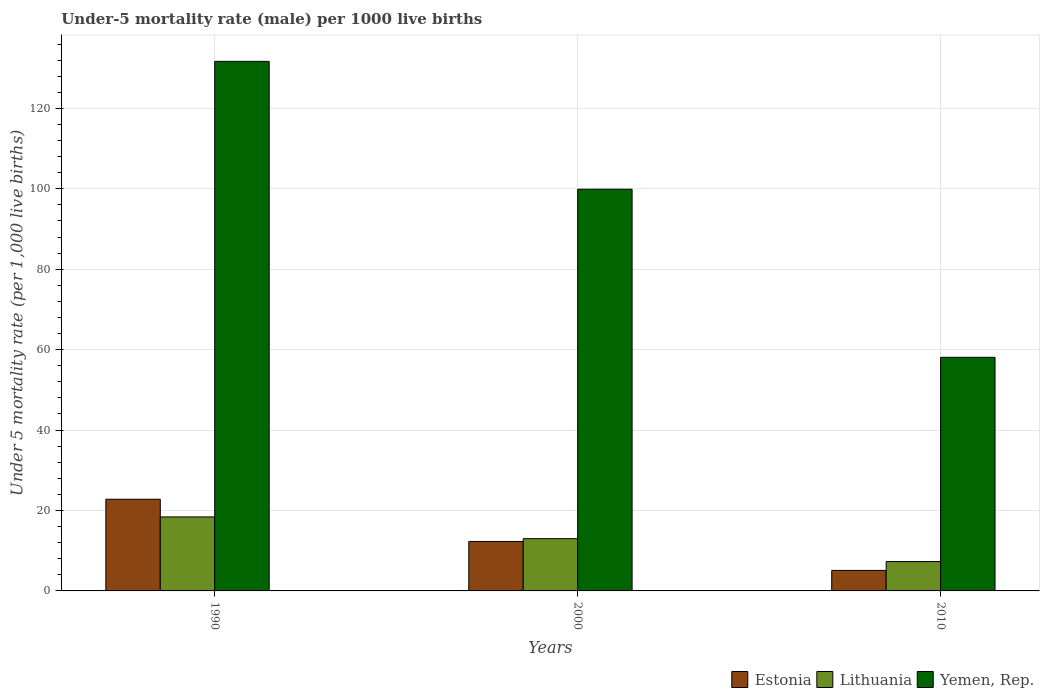How many groups of bars are there?
Give a very brief answer. 3. Are the number of bars per tick equal to the number of legend labels?
Offer a very short reply. Yes. How many bars are there on the 1st tick from the left?
Offer a terse response. 3. What is the label of the 3rd group of bars from the left?
Give a very brief answer. 2010. Across all years, what is the minimum under-five mortality rate in Lithuania?
Keep it short and to the point. 7.3. In which year was the under-five mortality rate in Lithuania maximum?
Offer a terse response. 1990. What is the total under-five mortality rate in Lithuania in the graph?
Make the answer very short. 38.7. What is the difference between the under-five mortality rate in Estonia in 2000 and that in 2010?
Ensure brevity in your answer.  7.2. What is the difference between the under-five mortality rate in Lithuania in 2000 and the under-five mortality rate in Estonia in 1990?
Make the answer very short. -9.8. What is the average under-five mortality rate in Lithuania per year?
Your answer should be very brief. 12.9. In the year 2000, what is the difference between the under-five mortality rate in Yemen, Rep. and under-five mortality rate in Estonia?
Keep it short and to the point. 87.6. What is the ratio of the under-five mortality rate in Lithuania in 1990 to that in 2000?
Your answer should be very brief. 1.42. Is the difference between the under-five mortality rate in Yemen, Rep. in 1990 and 2010 greater than the difference between the under-five mortality rate in Estonia in 1990 and 2010?
Your response must be concise. Yes. What is the difference between the highest and the second highest under-five mortality rate in Lithuania?
Ensure brevity in your answer.  5.4. What is the difference between the highest and the lowest under-five mortality rate in Estonia?
Your response must be concise. 17.7. What does the 3rd bar from the left in 2000 represents?
Provide a short and direct response. Yemen, Rep. What does the 2nd bar from the right in 2000 represents?
Make the answer very short. Lithuania. How many bars are there?
Offer a terse response. 9. Are all the bars in the graph horizontal?
Your response must be concise. No. How many years are there in the graph?
Ensure brevity in your answer.  3. Does the graph contain grids?
Keep it short and to the point. Yes. How are the legend labels stacked?
Provide a succinct answer. Horizontal. What is the title of the graph?
Give a very brief answer. Under-5 mortality rate (male) per 1000 live births. Does "Zimbabwe" appear as one of the legend labels in the graph?
Provide a short and direct response. No. What is the label or title of the Y-axis?
Provide a succinct answer. Under 5 mortality rate (per 1,0 live births). What is the Under 5 mortality rate (per 1,000 live births) in Estonia in 1990?
Offer a terse response. 22.8. What is the Under 5 mortality rate (per 1,000 live births) in Yemen, Rep. in 1990?
Ensure brevity in your answer.  131.7. What is the Under 5 mortality rate (per 1,000 live births) in Estonia in 2000?
Make the answer very short. 12.3. What is the Under 5 mortality rate (per 1,000 live births) of Lithuania in 2000?
Provide a short and direct response. 13. What is the Under 5 mortality rate (per 1,000 live births) of Yemen, Rep. in 2000?
Ensure brevity in your answer.  99.9. What is the Under 5 mortality rate (per 1,000 live births) of Estonia in 2010?
Your answer should be very brief. 5.1. What is the Under 5 mortality rate (per 1,000 live births) of Lithuania in 2010?
Keep it short and to the point. 7.3. What is the Under 5 mortality rate (per 1,000 live births) in Yemen, Rep. in 2010?
Offer a very short reply. 58.1. Across all years, what is the maximum Under 5 mortality rate (per 1,000 live births) of Estonia?
Provide a short and direct response. 22.8. Across all years, what is the maximum Under 5 mortality rate (per 1,000 live births) in Yemen, Rep.?
Offer a very short reply. 131.7. Across all years, what is the minimum Under 5 mortality rate (per 1,000 live births) of Yemen, Rep.?
Ensure brevity in your answer.  58.1. What is the total Under 5 mortality rate (per 1,000 live births) of Estonia in the graph?
Offer a very short reply. 40.2. What is the total Under 5 mortality rate (per 1,000 live births) of Lithuania in the graph?
Your response must be concise. 38.7. What is the total Under 5 mortality rate (per 1,000 live births) of Yemen, Rep. in the graph?
Offer a terse response. 289.7. What is the difference between the Under 5 mortality rate (per 1,000 live births) of Lithuania in 1990 and that in 2000?
Ensure brevity in your answer.  5.4. What is the difference between the Under 5 mortality rate (per 1,000 live births) of Yemen, Rep. in 1990 and that in 2000?
Your answer should be compact. 31.8. What is the difference between the Under 5 mortality rate (per 1,000 live births) of Lithuania in 1990 and that in 2010?
Offer a terse response. 11.1. What is the difference between the Under 5 mortality rate (per 1,000 live births) in Yemen, Rep. in 1990 and that in 2010?
Provide a succinct answer. 73.6. What is the difference between the Under 5 mortality rate (per 1,000 live births) of Estonia in 2000 and that in 2010?
Your answer should be compact. 7.2. What is the difference between the Under 5 mortality rate (per 1,000 live births) in Lithuania in 2000 and that in 2010?
Offer a very short reply. 5.7. What is the difference between the Under 5 mortality rate (per 1,000 live births) of Yemen, Rep. in 2000 and that in 2010?
Ensure brevity in your answer.  41.8. What is the difference between the Under 5 mortality rate (per 1,000 live births) of Estonia in 1990 and the Under 5 mortality rate (per 1,000 live births) of Yemen, Rep. in 2000?
Your answer should be compact. -77.1. What is the difference between the Under 5 mortality rate (per 1,000 live births) of Lithuania in 1990 and the Under 5 mortality rate (per 1,000 live births) of Yemen, Rep. in 2000?
Offer a terse response. -81.5. What is the difference between the Under 5 mortality rate (per 1,000 live births) of Estonia in 1990 and the Under 5 mortality rate (per 1,000 live births) of Yemen, Rep. in 2010?
Your response must be concise. -35.3. What is the difference between the Under 5 mortality rate (per 1,000 live births) in Lithuania in 1990 and the Under 5 mortality rate (per 1,000 live births) in Yemen, Rep. in 2010?
Ensure brevity in your answer.  -39.7. What is the difference between the Under 5 mortality rate (per 1,000 live births) of Estonia in 2000 and the Under 5 mortality rate (per 1,000 live births) of Lithuania in 2010?
Ensure brevity in your answer.  5. What is the difference between the Under 5 mortality rate (per 1,000 live births) of Estonia in 2000 and the Under 5 mortality rate (per 1,000 live births) of Yemen, Rep. in 2010?
Give a very brief answer. -45.8. What is the difference between the Under 5 mortality rate (per 1,000 live births) in Lithuania in 2000 and the Under 5 mortality rate (per 1,000 live births) in Yemen, Rep. in 2010?
Provide a succinct answer. -45.1. What is the average Under 5 mortality rate (per 1,000 live births) in Estonia per year?
Offer a terse response. 13.4. What is the average Under 5 mortality rate (per 1,000 live births) of Lithuania per year?
Offer a very short reply. 12.9. What is the average Under 5 mortality rate (per 1,000 live births) of Yemen, Rep. per year?
Provide a succinct answer. 96.57. In the year 1990, what is the difference between the Under 5 mortality rate (per 1,000 live births) of Estonia and Under 5 mortality rate (per 1,000 live births) of Lithuania?
Offer a very short reply. 4.4. In the year 1990, what is the difference between the Under 5 mortality rate (per 1,000 live births) in Estonia and Under 5 mortality rate (per 1,000 live births) in Yemen, Rep.?
Offer a very short reply. -108.9. In the year 1990, what is the difference between the Under 5 mortality rate (per 1,000 live births) of Lithuania and Under 5 mortality rate (per 1,000 live births) of Yemen, Rep.?
Your answer should be compact. -113.3. In the year 2000, what is the difference between the Under 5 mortality rate (per 1,000 live births) in Estonia and Under 5 mortality rate (per 1,000 live births) in Yemen, Rep.?
Your answer should be compact. -87.6. In the year 2000, what is the difference between the Under 5 mortality rate (per 1,000 live births) in Lithuania and Under 5 mortality rate (per 1,000 live births) in Yemen, Rep.?
Give a very brief answer. -86.9. In the year 2010, what is the difference between the Under 5 mortality rate (per 1,000 live births) of Estonia and Under 5 mortality rate (per 1,000 live births) of Lithuania?
Provide a short and direct response. -2.2. In the year 2010, what is the difference between the Under 5 mortality rate (per 1,000 live births) of Estonia and Under 5 mortality rate (per 1,000 live births) of Yemen, Rep.?
Make the answer very short. -53. In the year 2010, what is the difference between the Under 5 mortality rate (per 1,000 live births) of Lithuania and Under 5 mortality rate (per 1,000 live births) of Yemen, Rep.?
Your response must be concise. -50.8. What is the ratio of the Under 5 mortality rate (per 1,000 live births) in Estonia in 1990 to that in 2000?
Your answer should be compact. 1.85. What is the ratio of the Under 5 mortality rate (per 1,000 live births) in Lithuania in 1990 to that in 2000?
Ensure brevity in your answer.  1.42. What is the ratio of the Under 5 mortality rate (per 1,000 live births) of Yemen, Rep. in 1990 to that in 2000?
Ensure brevity in your answer.  1.32. What is the ratio of the Under 5 mortality rate (per 1,000 live births) of Estonia in 1990 to that in 2010?
Your answer should be compact. 4.47. What is the ratio of the Under 5 mortality rate (per 1,000 live births) in Lithuania in 1990 to that in 2010?
Keep it short and to the point. 2.52. What is the ratio of the Under 5 mortality rate (per 1,000 live births) of Yemen, Rep. in 1990 to that in 2010?
Provide a short and direct response. 2.27. What is the ratio of the Under 5 mortality rate (per 1,000 live births) in Estonia in 2000 to that in 2010?
Provide a short and direct response. 2.41. What is the ratio of the Under 5 mortality rate (per 1,000 live births) in Lithuania in 2000 to that in 2010?
Your answer should be compact. 1.78. What is the ratio of the Under 5 mortality rate (per 1,000 live births) in Yemen, Rep. in 2000 to that in 2010?
Your answer should be very brief. 1.72. What is the difference between the highest and the second highest Under 5 mortality rate (per 1,000 live births) in Yemen, Rep.?
Your answer should be compact. 31.8. What is the difference between the highest and the lowest Under 5 mortality rate (per 1,000 live births) of Estonia?
Your answer should be compact. 17.7. What is the difference between the highest and the lowest Under 5 mortality rate (per 1,000 live births) of Yemen, Rep.?
Keep it short and to the point. 73.6. 